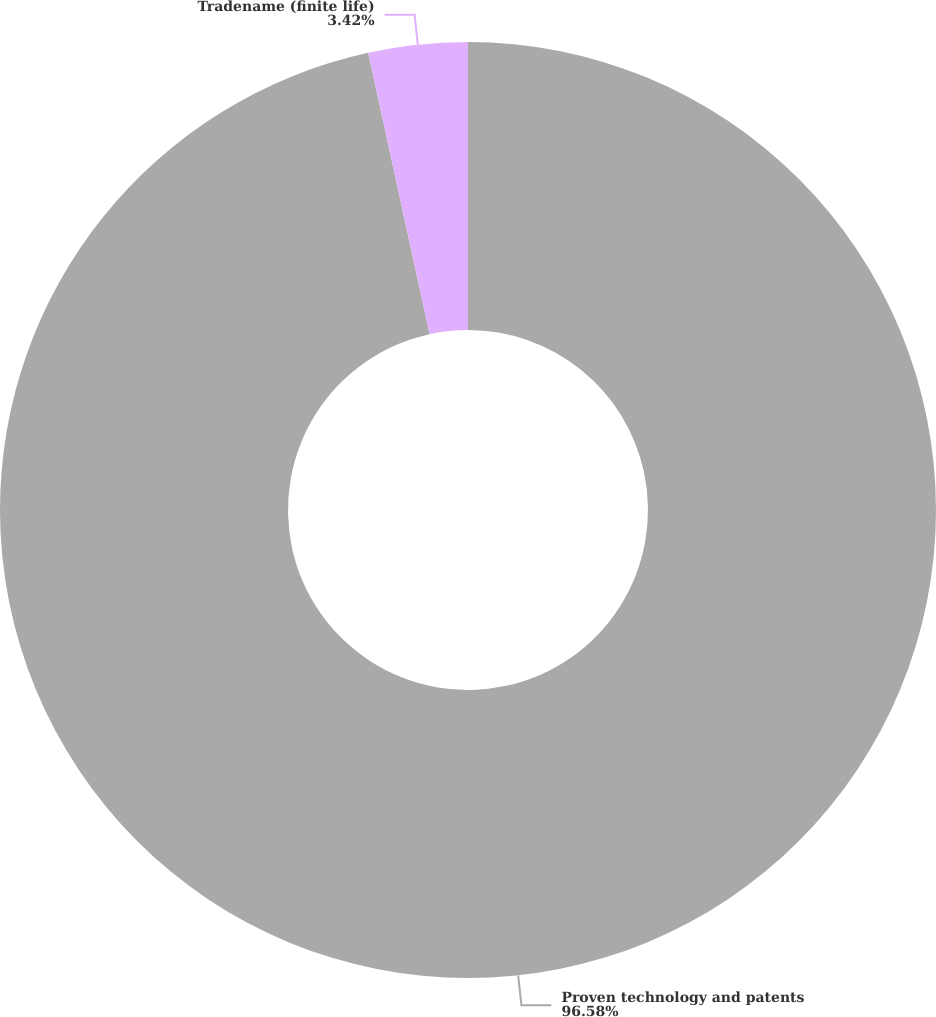Convert chart to OTSL. <chart><loc_0><loc_0><loc_500><loc_500><pie_chart><fcel>Proven technology and patents<fcel>Tradename (finite life)<nl><fcel>96.58%<fcel>3.42%<nl></chart> 